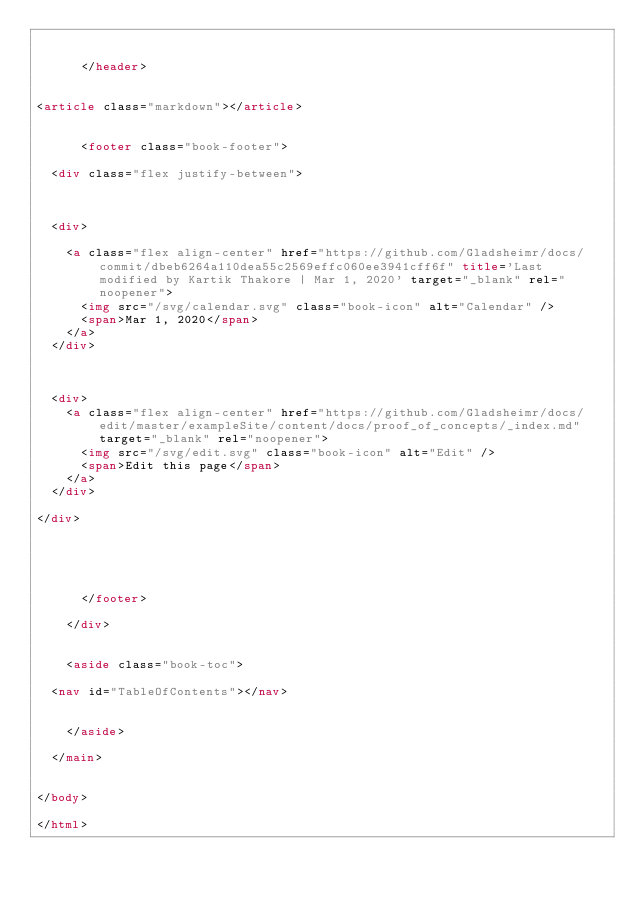<code> <loc_0><loc_0><loc_500><loc_500><_HTML_>  
 
      </header>

      
<article class="markdown"></article>
 

      <footer class="book-footer">
        
  <div class="flex justify-between">



  <div>
    
    <a class="flex align-center" href="https://github.com/Gladsheimr/docs/commit/dbeb6264a110dea55c2569effc060ee3941cff6f" title='Last modified by Kartik Thakore | Mar 1, 2020' target="_blank" rel="noopener">
      <img src="/svg/calendar.svg" class="book-icon" alt="Calendar" />
      <span>Mar 1, 2020</span>
    </a>
  </div>



  <div>
    <a class="flex align-center" href="https://github.com/Gladsheimr/docs/edit/master/exampleSite/content/docs/proof_of_concepts/_index.md" target="_blank" rel="noopener">
      <img src="/svg/edit.svg" class="book-icon" alt="Edit" />
      <span>Edit this page</span>
    </a>
  </div>

</div>

 
        
  
 
      </footer>
      
    </div>

    
    <aside class="book-toc">
      
  <nav id="TableOfContents"></nav>

 
    </aside>
    
  </main>

  
</body>

</html>












</code> 